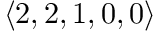<formula> <loc_0><loc_0><loc_500><loc_500>\langle 2 , 2 , 1 , 0 , 0 \rangle</formula> 